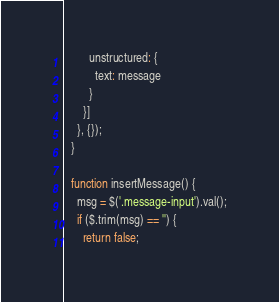Convert code to text. <code><loc_0><loc_0><loc_500><loc_500><_JavaScript_>        unstructured: {
          text: message
        }
      }]
    }, {});
  }

  function insertMessage() {
    msg = $('.message-input').val();
    if ($.trim(msg) == '') {
      return false;</code> 